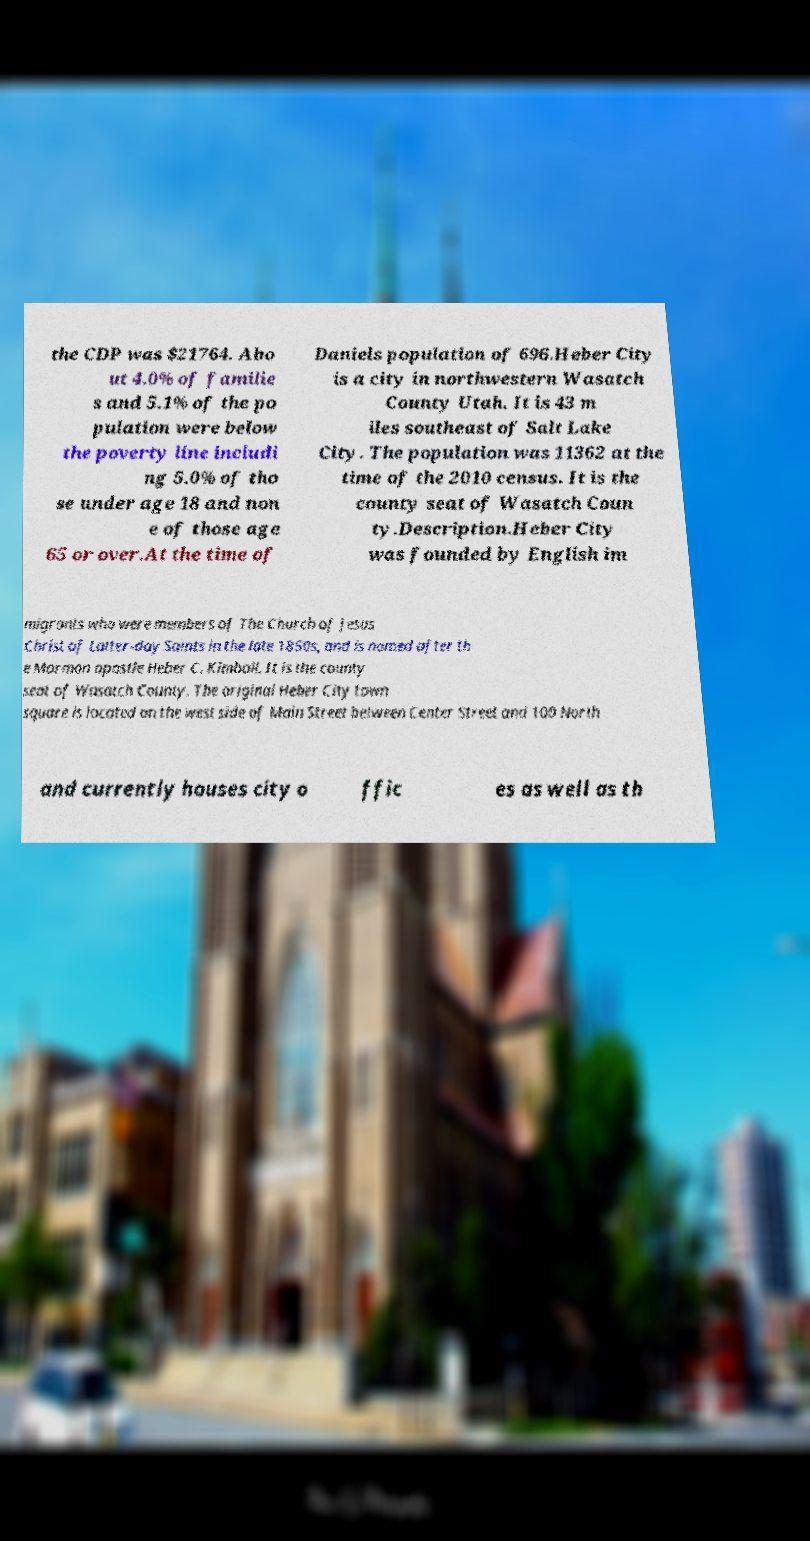There's text embedded in this image that I need extracted. Can you transcribe it verbatim? the CDP was $21764. Abo ut 4.0% of familie s and 5.1% of the po pulation were below the poverty line includi ng 5.0% of tho se under age 18 and non e of those age 65 or over.At the time of Daniels population of 696.Heber City is a city in northwestern Wasatch County Utah. It is 43 m iles southeast of Salt Lake City. The population was 11362 at the time of the 2010 census. It is the county seat of Wasatch Coun ty.Description.Heber City was founded by English im migrants who were members of The Church of Jesus Christ of Latter-day Saints in the late 1850s, and is named after th e Mormon apostle Heber C. Kimball. It is the county seat of Wasatch County. The original Heber City town square is located on the west side of Main Street between Center Street and 100 North and currently houses city o ffic es as well as th 